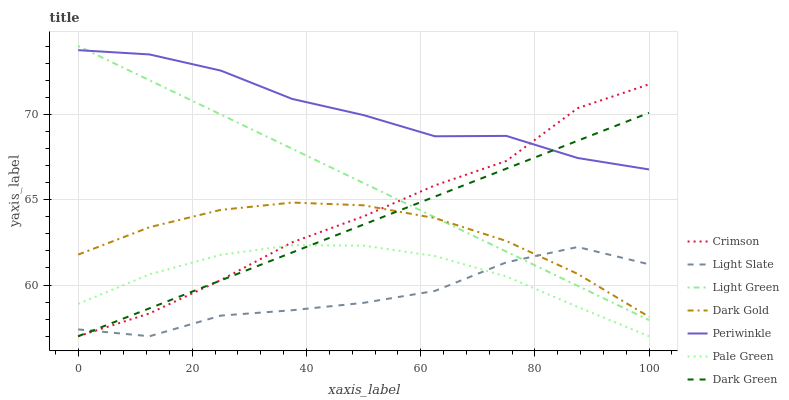Does Pale Green have the minimum area under the curve?
Answer yes or no. No. Does Pale Green have the maximum area under the curve?
Answer yes or no. No. Is Pale Green the smoothest?
Answer yes or no. No. Is Pale Green the roughest?
Answer yes or no. No. Does Periwinkle have the lowest value?
Answer yes or no. No. Does Pale Green have the highest value?
Answer yes or no. No. Is Dark Gold less than Periwinkle?
Answer yes or no. Yes. Is Dark Gold greater than Pale Green?
Answer yes or no. Yes. Does Dark Gold intersect Periwinkle?
Answer yes or no. No. 